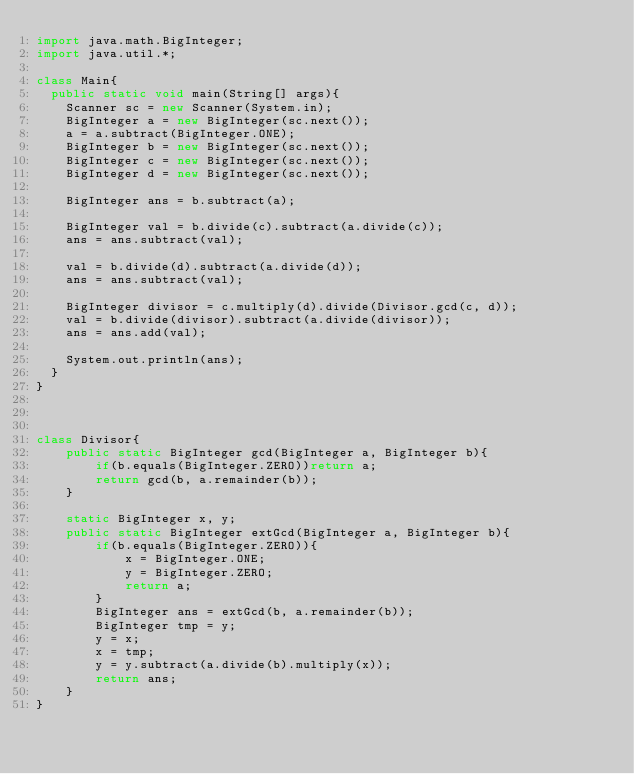<code> <loc_0><loc_0><loc_500><loc_500><_Java_>import java.math.BigInteger;
import java.util.*;

class Main{
	public static void main(String[] args){
		Scanner sc = new Scanner(System.in);
		BigInteger a = new BigInteger(sc.next());
		a = a.subtract(BigInteger.ONE);
		BigInteger b = new BigInteger(sc.next());
		BigInteger c = new BigInteger(sc.next());
		BigInteger d = new BigInteger(sc.next());

		BigInteger ans = b.subtract(a);

		BigInteger val = b.divide(c).subtract(a.divide(c));
		ans = ans.subtract(val);

		val = b.divide(d).subtract(a.divide(d));
		ans = ans.subtract(val);

		BigInteger divisor = c.multiply(d).divide(Divisor.gcd(c, d));
		val = b.divide(divisor).subtract(a.divide(divisor));
		ans = ans.add(val);

		System.out.println(ans);
	}
}



class Divisor{
    public static BigInteger gcd(BigInteger a, BigInteger b){
        if(b.equals(BigInteger.ZERO))return a;
        return gcd(b, a.remainder(b));
    }

    static BigInteger x, y;
    public static BigInteger extGcd(BigInteger a, BigInteger b){
        if(b.equals(BigInteger.ZERO)){
            x = BigInteger.ONE;
            y = BigInteger.ZERO;
            return a;
        }
        BigInteger ans = extGcd(b, a.remainder(b));
        BigInteger tmp = y;
        y = x;
        x = tmp;
        y = y.subtract(a.divide(b).multiply(x));
        return ans;
    }
}</code> 